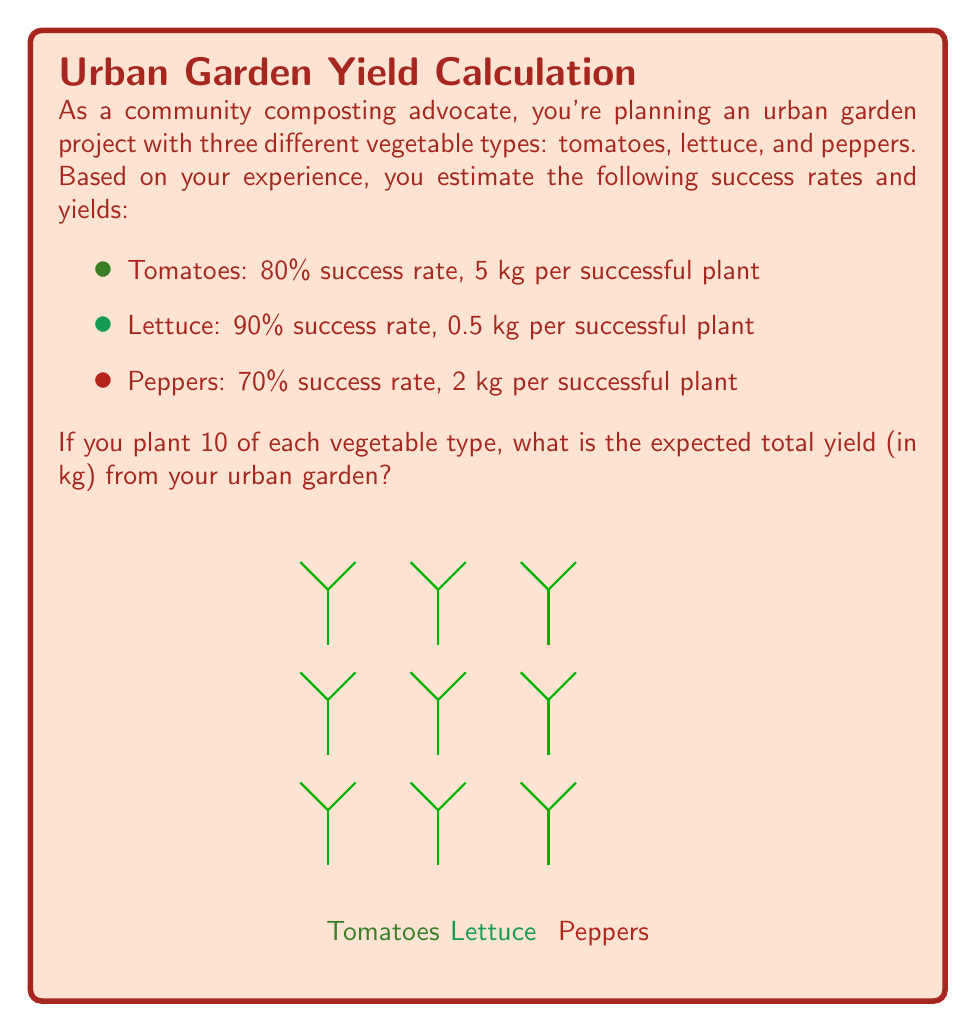Give your solution to this math problem. Let's break this down step-by-step:

1) First, we need to calculate the expected yield for each vegetable type:

   Expected yield = Number of plants × Success rate × Yield per successful plant

2) For tomatoes:
   $$ 10 \times 0.80 \times 5 \text{ kg} = 40 \text{ kg} $$

3) For lettuce:
   $$ 10 \times 0.90 \times 0.5 \text{ kg} = 4.5 \text{ kg} $$

4) For peppers:
   $$ 10 \times 0.70 \times 2 \text{ kg} = 14 \text{ kg} $$

5) To get the total expected yield, we sum the expected yields of all vegetable types:

   Total expected yield = Expected yield (tomatoes) + Expected yield (lettuce) + Expected yield (peppers)
   
   $$ 40 \text{ kg} + 4.5 \text{ kg} + 14 \text{ kg} = 58.5 \text{ kg} $$

Therefore, the expected total yield from your urban garden is 58.5 kg.
Answer: 58.5 kg 